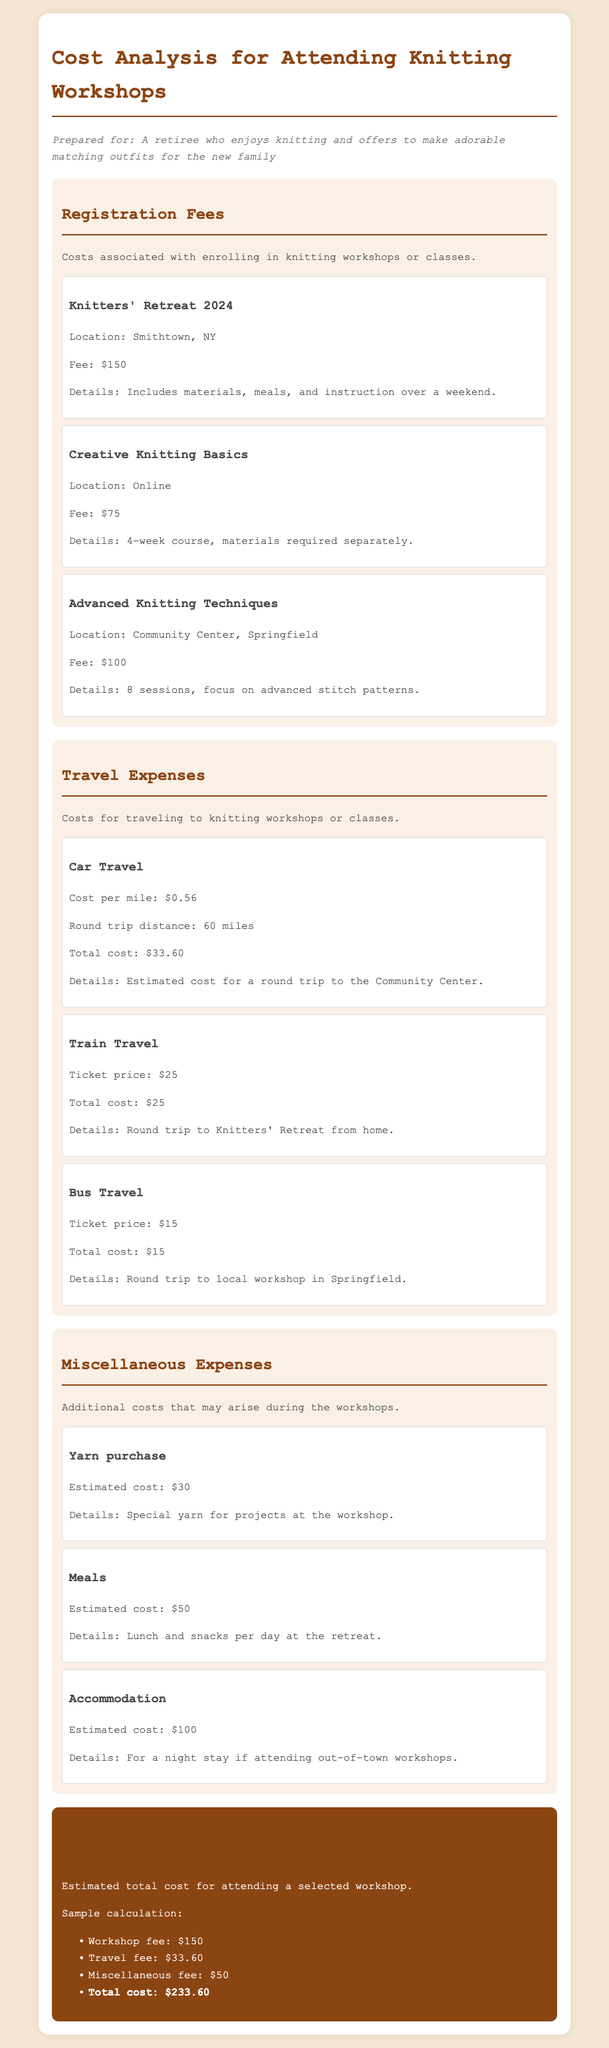What is the fee for the Knitters' Retreat 2024? The fee for the Knitters' Retreat 2024 is stated in the document as $150.
Answer: $150 What is the travel cost for a round trip by car? The document details the cost of car travel as $33.60 for a round trip.
Answer: $33.60 How many sessions does the Advanced Knitting Techniques workshop have? The document indicates that the Advanced Knitting Techniques workshop has 8 sessions.
Answer: 8 sessions What is the estimated cost for yarn purchase? According to the document, the estimated cost for yarn purchase is $30.
Answer: $30 What is the total estimated cost for attending the selected workshop? The total estimated cost for attending the workshop is calculated in the document and presented as $233.60.
Answer: $233.60 What is the cost per mile for car travel? The document specifies the cost per mile for car travel as $0.56.
Answer: $0.56 What is the title of the online workshop? The title of the online workshop is Creative Knitting Basics.
Answer: Creative Knitting Basics What is included in the registration fee for the Knitters' Retreat 2024? The registration fee for the Knitters' Retreat 2024 includes materials, meals, and instruction over a weekend, as mentioned in the document.
Answer: Materials, meals, instruction What is the estimated accommodation cost if attending out-of-town workshops? The document states that the estimated accommodation cost is $100.
Answer: $100 